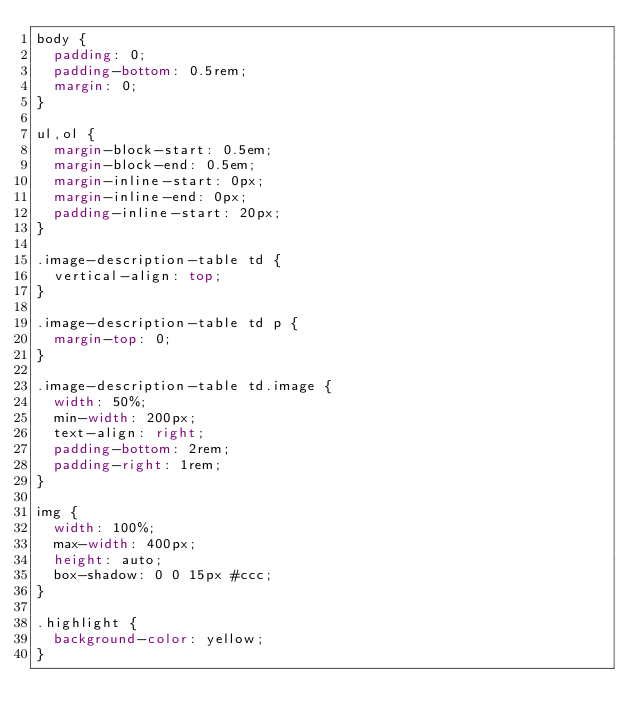<code> <loc_0><loc_0><loc_500><loc_500><_CSS_>body {
  padding: 0;
  padding-bottom: 0.5rem;
  margin: 0;
}

ul,ol {
  margin-block-start: 0.5em;
  margin-block-end: 0.5em;
  margin-inline-start: 0px;
  margin-inline-end: 0px;
  padding-inline-start: 20px;
}

.image-description-table td {
  vertical-align: top;
}

.image-description-table td p {
  margin-top: 0;
}

.image-description-table td.image {
  width: 50%;
  min-width: 200px;
  text-align: right;
  padding-bottom: 2rem;
  padding-right: 1rem;
}

img {
  width: 100%;
  max-width: 400px;
  height: auto;
  box-shadow: 0 0 15px #ccc;
}

.highlight {
  background-color: yellow;
}
</code> 